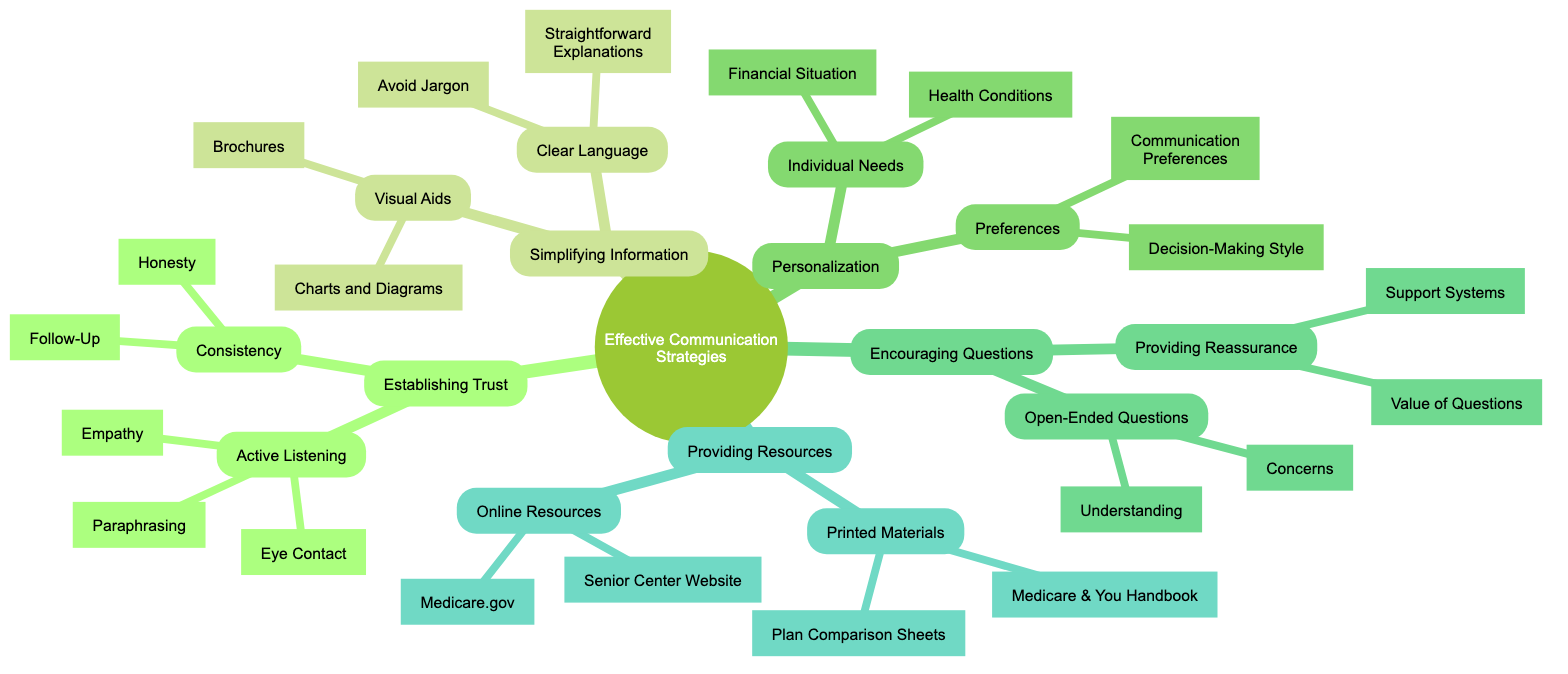What are the main categories of effective communication strategies? The diagram displays five main categories: Establishing Trust, Simplifying Information, Personalization, Encouraging Questions, and Providing Resources. Each category branches out into more specific strategies.
Answer: Establishing Trust, Simplifying Information, Personalization, Encouraging Questions, Providing Resources How many strategies are listed under Establishing Trust? Under Establishing Trust, there are two main strategies: Active Listening and Consistency. Each of these strategies has specific elements listed under them.
Answer: 2 What is an example of a visual aid used to explain Medicare plans? The diagram includes "Charts and Diagrams" as a listed strategy under Visual Aids, which indicates a type of visual aid that can be used.
Answer: Charts and Diagrams What do Empathy and Eye Contact fall under in the diagram? Empathy and Eye Contact are both specific strategies that fall under the broader category of Active Listening, which is one of the strategies under Establishing Trust.
Answer: Active Listening How many sub-strategies are included in the Encouraging Questions section? The Encouraging Questions section contains two main sub-strategies: Open-Ended Questions and Providing Reassurance. Each of these has specific strategies detailed within them.
Answer: 2 What type of resources does the Providing Resources category include? The Providing Resources category is split into two types: Printed Materials and Online Resources, which provide various forms of support for seniors.
Answer: Printed Materials and Online Resources What is the purpose of Paraphrasing as described in the diagram? Paraphrasing is meant to restate the senior's concerns in the assistant's own words to show understanding, thereby building trust and clarity in communication.
Answer: Show understanding Which method emphasizes understanding the senior’s financial situation? The method referred to in the diagram is called Individual Needs, which includes understanding the financial situation as a critical aspect of effective communication about Medicare options.
Answer: Individual Needs What specific printed material is suggested for seniors to reference? The Medicare & You Handbook is suggested as a printed material for detailed reference, aiding seniors in understanding Medicare.
Answer: Medicare & You Handbook 